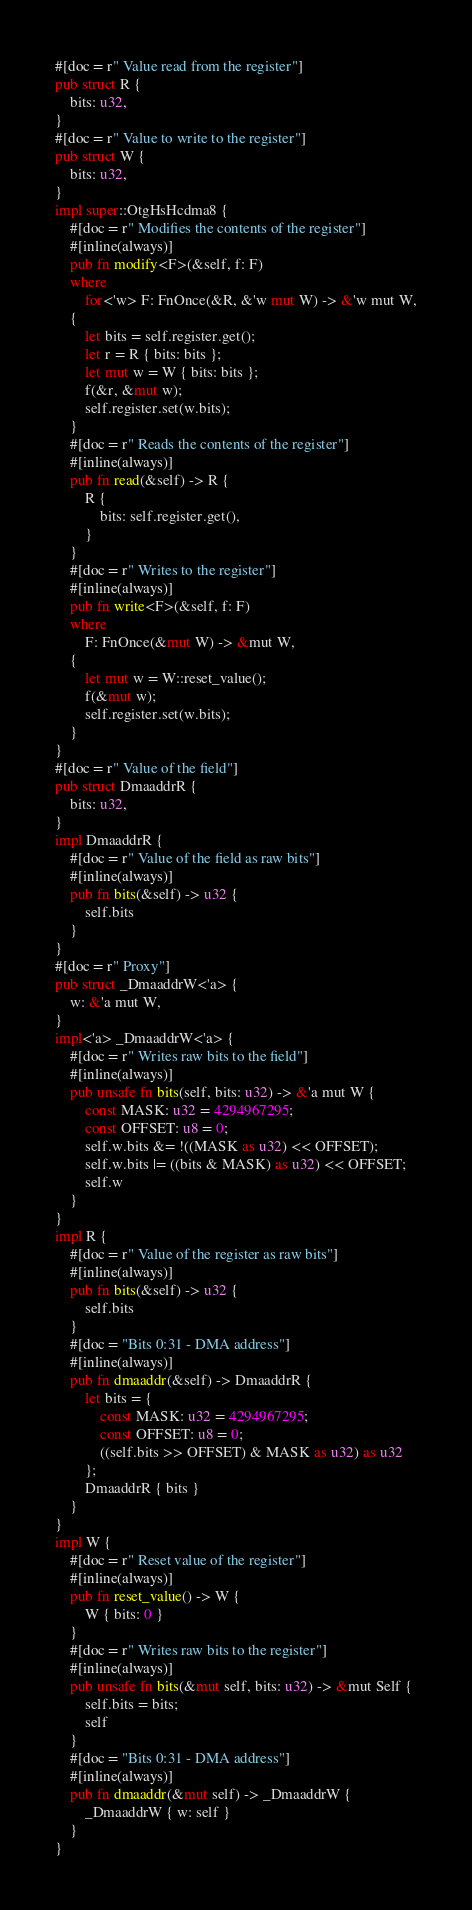Convert code to text. <code><loc_0><loc_0><loc_500><loc_500><_Rust_>#[doc = r" Value read from the register"]
pub struct R {
    bits: u32,
}
#[doc = r" Value to write to the register"]
pub struct W {
    bits: u32,
}
impl super::OtgHsHcdma8 {
    #[doc = r" Modifies the contents of the register"]
    #[inline(always)]
    pub fn modify<F>(&self, f: F)
    where
        for<'w> F: FnOnce(&R, &'w mut W) -> &'w mut W,
    {
        let bits = self.register.get();
        let r = R { bits: bits };
        let mut w = W { bits: bits };
        f(&r, &mut w);
        self.register.set(w.bits);
    }
    #[doc = r" Reads the contents of the register"]
    #[inline(always)]
    pub fn read(&self) -> R {
        R {
            bits: self.register.get(),
        }
    }
    #[doc = r" Writes to the register"]
    #[inline(always)]
    pub fn write<F>(&self, f: F)
    where
        F: FnOnce(&mut W) -> &mut W,
    {
        let mut w = W::reset_value();
        f(&mut w);
        self.register.set(w.bits);
    }
}
#[doc = r" Value of the field"]
pub struct DmaaddrR {
    bits: u32,
}
impl DmaaddrR {
    #[doc = r" Value of the field as raw bits"]
    #[inline(always)]
    pub fn bits(&self) -> u32 {
        self.bits
    }
}
#[doc = r" Proxy"]
pub struct _DmaaddrW<'a> {
    w: &'a mut W,
}
impl<'a> _DmaaddrW<'a> {
    #[doc = r" Writes raw bits to the field"]
    #[inline(always)]
    pub unsafe fn bits(self, bits: u32) -> &'a mut W {
        const MASK: u32 = 4294967295;
        const OFFSET: u8 = 0;
        self.w.bits &= !((MASK as u32) << OFFSET);
        self.w.bits |= ((bits & MASK) as u32) << OFFSET;
        self.w
    }
}
impl R {
    #[doc = r" Value of the register as raw bits"]
    #[inline(always)]
    pub fn bits(&self) -> u32 {
        self.bits
    }
    #[doc = "Bits 0:31 - DMA address"]
    #[inline(always)]
    pub fn dmaaddr(&self) -> DmaaddrR {
        let bits = {
            const MASK: u32 = 4294967295;
            const OFFSET: u8 = 0;
            ((self.bits >> OFFSET) & MASK as u32) as u32
        };
        DmaaddrR { bits }
    }
}
impl W {
    #[doc = r" Reset value of the register"]
    #[inline(always)]
    pub fn reset_value() -> W {
        W { bits: 0 }
    }
    #[doc = r" Writes raw bits to the register"]
    #[inline(always)]
    pub unsafe fn bits(&mut self, bits: u32) -> &mut Self {
        self.bits = bits;
        self
    }
    #[doc = "Bits 0:31 - DMA address"]
    #[inline(always)]
    pub fn dmaaddr(&mut self) -> _DmaaddrW {
        _DmaaddrW { w: self }
    }
}
</code> 